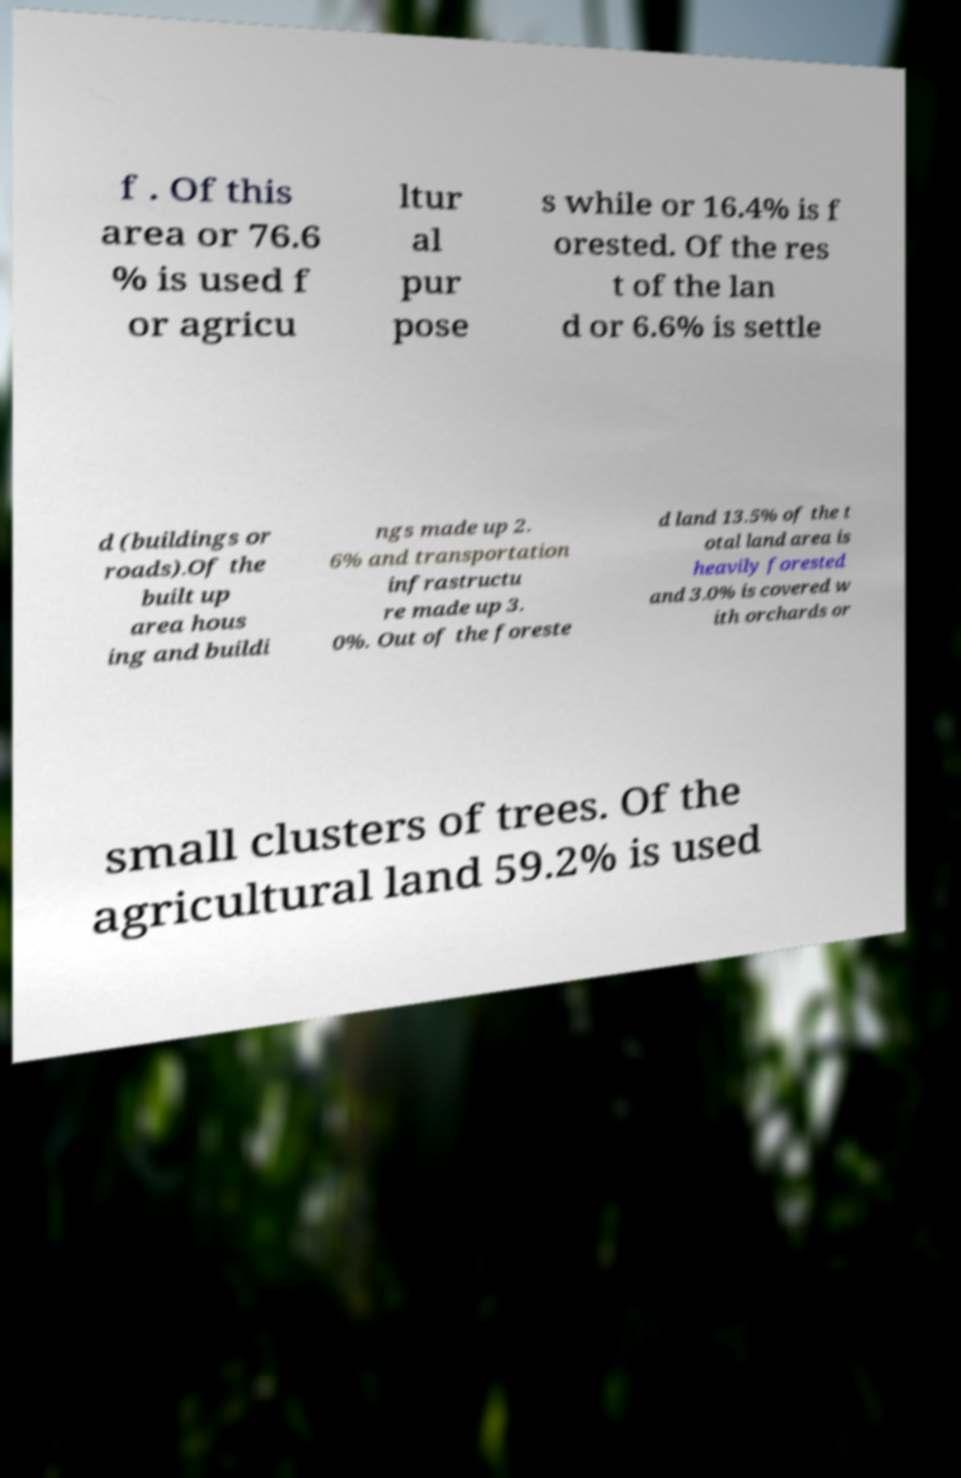I need the written content from this picture converted into text. Can you do that? f . Of this area or 76.6 % is used f or agricu ltur al pur pose s while or 16.4% is f orested. Of the res t of the lan d or 6.6% is settle d (buildings or roads).Of the built up area hous ing and buildi ngs made up 2. 6% and transportation infrastructu re made up 3. 0%. Out of the foreste d land 13.5% of the t otal land area is heavily forested and 3.0% is covered w ith orchards or small clusters of trees. Of the agricultural land 59.2% is used 